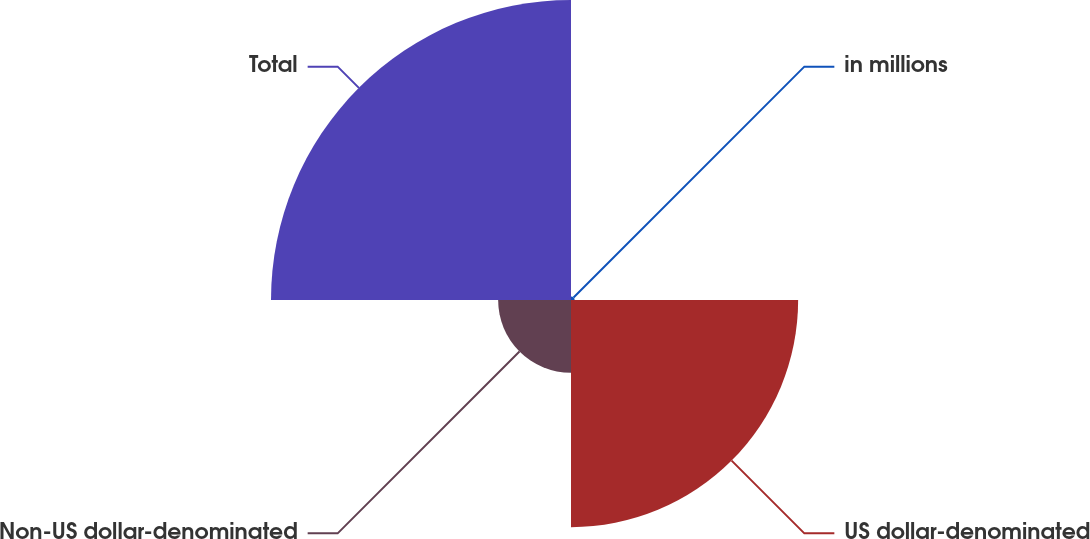<chart> <loc_0><loc_0><loc_500><loc_500><pie_chart><fcel>in millions<fcel>US dollar-denominated<fcel>Non-US dollar-denominated<fcel>Total<nl><fcel>0.6%<fcel>37.63%<fcel>12.07%<fcel>49.7%<nl></chart> 